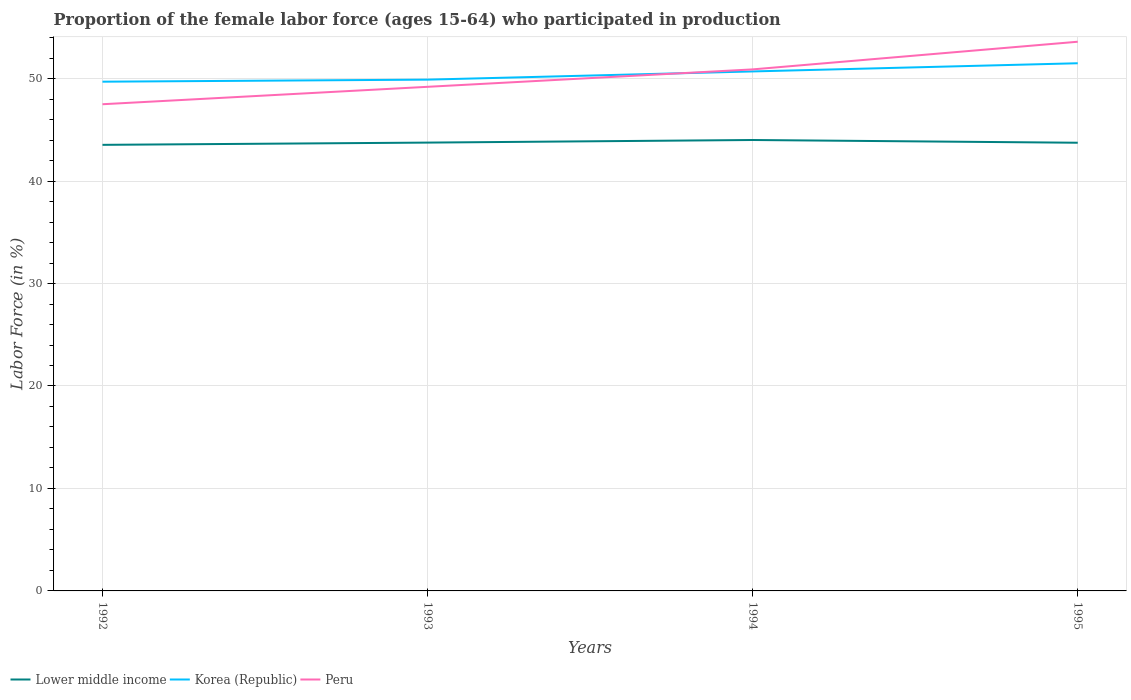How many different coloured lines are there?
Keep it short and to the point. 3. Across all years, what is the maximum proportion of the female labor force who participated in production in Lower middle income?
Give a very brief answer. 43.54. In which year was the proportion of the female labor force who participated in production in Peru maximum?
Your response must be concise. 1992. What is the total proportion of the female labor force who participated in production in Peru in the graph?
Give a very brief answer. -3.4. What is the difference between the highest and the second highest proportion of the female labor force who participated in production in Peru?
Give a very brief answer. 6.1. Is the proportion of the female labor force who participated in production in Korea (Republic) strictly greater than the proportion of the female labor force who participated in production in Peru over the years?
Provide a succinct answer. No. How many lines are there?
Provide a succinct answer. 3. What is the difference between two consecutive major ticks on the Y-axis?
Provide a short and direct response. 10. Does the graph contain grids?
Make the answer very short. Yes. What is the title of the graph?
Your response must be concise. Proportion of the female labor force (ages 15-64) who participated in production. What is the label or title of the Y-axis?
Ensure brevity in your answer.  Labor Force (in %). What is the Labor Force (in %) of Lower middle income in 1992?
Make the answer very short. 43.54. What is the Labor Force (in %) of Korea (Republic) in 1992?
Make the answer very short. 49.7. What is the Labor Force (in %) of Peru in 1992?
Ensure brevity in your answer.  47.5. What is the Labor Force (in %) in Lower middle income in 1993?
Ensure brevity in your answer.  43.76. What is the Labor Force (in %) of Korea (Republic) in 1993?
Make the answer very short. 49.9. What is the Labor Force (in %) in Peru in 1993?
Your response must be concise. 49.2. What is the Labor Force (in %) in Lower middle income in 1994?
Make the answer very short. 44.01. What is the Labor Force (in %) in Korea (Republic) in 1994?
Offer a very short reply. 50.7. What is the Labor Force (in %) in Peru in 1994?
Keep it short and to the point. 50.9. What is the Labor Force (in %) in Lower middle income in 1995?
Your answer should be very brief. 43.74. What is the Labor Force (in %) of Korea (Republic) in 1995?
Provide a short and direct response. 51.5. What is the Labor Force (in %) in Peru in 1995?
Make the answer very short. 53.6. Across all years, what is the maximum Labor Force (in %) in Lower middle income?
Keep it short and to the point. 44.01. Across all years, what is the maximum Labor Force (in %) in Korea (Republic)?
Your answer should be compact. 51.5. Across all years, what is the maximum Labor Force (in %) in Peru?
Offer a very short reply. 53.6. Across all years, what is the minimum Labor Force (in %) in Lower middle income?
Provide a succinct answer. 43.54. Across all years, what is the minimum Labor Force (in %) in Korea (Republic)?
Your response must be concise. 49.7. Across all years, what is the minimum Labor Force (in %) of Peru?
Give a very brief answer. 47.5. What is the total Labor Force (in %) in Lower middle income in the graph?
Ensure brevity in your answer.  175.05. What is the total Labor Force (in %) of Korea (Republic) in the graph?
Ensure brevity in your answer.  201.8. What is the total Labor Force (in %) of Peru in the graph?
Provide a succinct answer. 201.2. What is the difference between the Labor Force (in %) in Lower middle income in 1992 and that in 1993?
Provide a short and direct response. -0.22. What is the difference between the Labor Force (in %) in Lower middle income in 1992 and that in 1994?
Offer a terse response. -0.47. What is the difference between the Labor Force (in %) in Peru in 1992 and that in 1994?
Provide a succinct answer. -3.4. What is the difference between the Labor Force (in %) of Lower middle income in 1992 and that in 1995?
Provide a succinct answer. -0.21. What is the difference between the Labor Force (in %) of Korea (Republic) in 1992 and that in 1995?
Make the answer very short. -1.8. What is the difference between the Labor Force (in %) in Peru in 1992 and that in 1995?
Provide a succinct answer. -6.1. What is the difference between the Labor Force (in %) of Lower middle income in 1993 and that in 1994?
Offer a terse response. -0.25. What is the difference between the Labor Force (in %) in Lower middle income in 1993 and that in 1995?
Provide a succinct answer. 0.01. What is the difference between the Labor Force (in %) of Korea (Republic) in 1993 and that in 1995?
Your answer should be compact. -1.6. What is the difference between the Labor Force (in %) of Lower middle income in 1994 and that in 1995?
Provide a succinct answer. 0.27. What is the difference between the Labor Force (in %) of Korea (Republic) in 1994 and that in 1995?
Provide a succinct answer. -0.8. What is the difference between the Labor Force (in %) of Lower middle income in 1992 and the Labor Force (in %) of Korea (Republic) in 1993?
Offer a very short reply. -6.36. What is the difference between the Labor Force (in %) in Lower middle income in 1992 and the Labor Force (in %) in Peru in 1993?
Make the answer very short. -5.66. What is the difference between the Labor Force (in %) of Korea (Republic) in 1992 and the Labor Force (in %) of Peru in 1993?
Ensure brevity in your answer.  0.5. What is the difference between the Labor Force (in %) of Lower middle income in 1992 and the Labor Force (in %) of Korea (Republic) in 1994?
Keep it short and to the point. -7.16. What is the difference between the Labor Force (in %) of Lower middle income in 1992 and the Labor Force (in %) of Peru in 1994?
Keep it short and to the point. -7.36. What is the difference between the Labor Force (in %) in Lower middle income in 1992 and the Labor Force (in %) in Korea (Republic) in 1995?
Your answer should be very brief. -7.96. What is the difference between the Labor Force (in %) of Lower middle income in 1992 and the Labor Force (in %) of Peru in 1995?
Your answer should be very brief. -10.06. What is the difference between the Labor Force (in %) of Korea (Republic) in 1992 and the Labor Force (in %) of Peru in 1995?
Keep it short and to the point. -3.9. What is the difference between the Labor Force (in %) in Lower middle income in 1993 and the Labor Force (in %) in Korea (Republic) in 1994?
Your response must be concise. -6.94. What is the difference between the Labor Force (in %) of Lower middle income in 1993 and the Labor Force (in %) of Peru in 1994?
Your response must be concise. -7.14. What is the difference between the Labor Force (in %) in Korea (Republic) in 1993 and the Labor Force (in %) in Peru in 1994?
Provide a short and direct response. -1. What is the difference between the Labor Force (in %) in Lower middle income in 1993 and the Labor Force (in %) in Korea (Republic) in 1995?
Provide a succinct answer. -7.74. What is the difference between the Labor Force (in %) in Lower middle income in 1993 and the Labor Force (in %) in Peru in 1995?
Offer a terse response. -9.84. What is the difference between the Labor Force (in %) in Korea (Republic) in 1993 and the Labor Force (in %) in Peru in 1995?
Ensure brevity in your answer.  -3.7. What is the difference between the Labor Force (in %) in Lower middle income in 1994 and the Labor Force (in %) in Korea (Republic) in 1995?
Offer a very short reply. -7.49. What is the difference between the Labor Force (in %) of Lower middle income in 1994 and the Labor Force (in %) of Peru in 1995?
Your response must be concise. -9.59. What is the difference between the Labor Force (in %) in Korea (Republic) in 1994 and the Labor Force (in %) in Peru in 1995?
Give a very brief answer. -2.9. What is the average Labor Force (in %) in Lower middle income per year?
Ensure brevity in your answer.  43.76. What is the average Labor Force (in %) in Korea (Republic) per year?
Give a very brief answer. 50.45. What is the average Labor Force (in %) of Peru per year?
Make the answer very short. 50.3. In the year 1992, what is the difference between the Labor Force (in %) in Lower middle income and Labor Force (in %) in Korea (Republic)?
Provide a short and direct response. -6.16. In the year 1992, what is the difference between the Labor Force (in %) in Lower middle income and Labor Force (in %) in Peru?
Provide a short and direct response. -3.96. In the year 1993, what is the difference between the Labor Force (in %) in Lower middle income and Labor Force (in %) in Korea (Republic)?
Give a very brief answer. -6.14. In the year 1993, what is the difference between the Labor Force (in %) of Lower middle income and Labor Force (in %) of Peru?
Ensure brevity in your answer.  -5.44. In the year 1993, what is the difference between the Labor Force (in %) of Korea (Republic) and Labor Force (in %) of Peru?
Your answer should be very brief. 0.7. In the year 1994, what is the difference between the Labor Force (in %) of Lower middle income and Labor Force (in %) of Korea (Republic)?
Your response must be concise. -6.69. In the year 1994, what is the difference between the Labor Force (in %) of Lower middle income and Labor Force (in %) of Peru?
Offer a very short reply. -6.89. In the year 1995, what is the difference between the Labor Force (in %) of Lower middle income and Labor Force (in %) of Korea (Republic)?
Offer a very short reply. -7.76. In the year 1995, what is the difference between the Labor Force (in %) of Lower middle income and Labor Force (in %) of Peru?
Your answer should be very brief. -9.86. What is the ratio of the Labor Force (in %) of Korea (Republic) in 1992 to that in 1993?
Give a very brief answer. 1. What is the ratio of the Labor Force (in %) in Peru in 1992 to that in 1993?
Your answer should be very brief. 0.97. What is the ratio of the Labor Force (in %) of Lower middle income in 1992 to that in 1994?
Keep it short and to the point. 0.99. What is the ratio of the Labor Force (in %) of Korea (Republic) in 1992 to that in 1994?
Provide a succinct answer. 0.98. What is the ratio of the Labor Force (in %) in Peru in 1992 to that in 1994?
Your answer should be very brief. 0.93. What is the ratio of the Labor Force (in %) in Peru in 1992 to that in 1995?
Your response must be concise. 0.89. What is the ratio of the Labor Force (in %) in Lower middle income in 1993 to that in 1994?
Offer a very short reply. 0.99. What is the ratio of the Labor Force (in %) in Korea (Republic) in 1993 to that in 1994?
Provide a short and direct response. 0.98. What is the ratio of the Labor Force (in %) of Peru in 1993 to that in 1994?
Your response must be concise. 0.97. What is the ratio of the Labor Force (in %) in Lower middle income in 1993 to that in 1995?
Offer a very short reply. 1. What is the ratio of the Labor Force (in %) in Korea (Republic) in 1993 to that in 1995?
Offer a terse response. 0.97. What is the ratio of the Labor Force (in %) of Peru in 1993 to that in 1995?
Your answer should be very brief. 0.92. What is the ratio of the Labor Force (in %) in Korea (Republic) in 1994 to that in 1995?
Offer a very short reply. 0.98. What is the ratio of the Labor Force (in %) in Peru in 1994 to that in 1995?
Provide a short and direct response. 0.95. What is the difference between the highest and the second highest Labor Force (in %) of Lower middle income?
Provide a short and direct response. 0.25. What is the difference between the highest and the second highest Labor Force (in %) in Korea (Republic)?
Keep it short and to the point. 0.8. What is the difference between the highest and the second highest Labor Force (in %) of Peru?
Make the answer very short. 2.7. What is the difference between the highest and the lowest Labor Force (in %) of Lower middle income?
Your answer should be very brief. 0.47. What is the difference between the highest and the lowest Labor Force (in %) of Korea (Republic)?
Offer a terse response. 1.8. What is the difference between the highest and the lowest Labor Force (in %) of Peru?
Your answer should be compact. 6.1. 